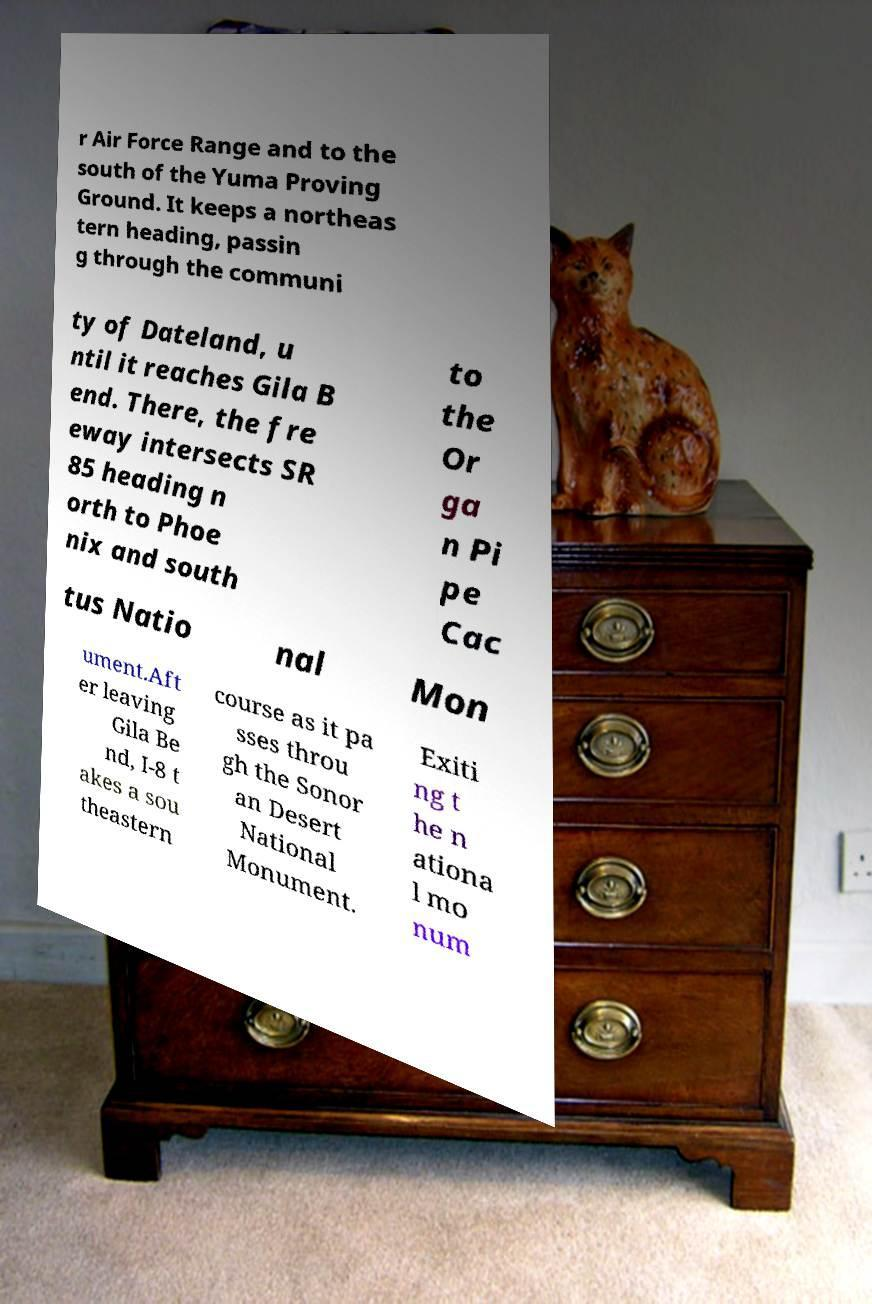For documentation purposes, I need the text within this image transcribed. Could you provide that? r Air Force Range and to the south of the Yuma Proving Ground. It keeps a northeas tern heading, passin g through the communi ty of Dateland, u ntil it reaches Gila B end. There, the fre eway intersects SR 85 heading n orth to Phoe nix and south to the Or ga n Pi pe Cac tus Natio nal Mon ument.Aft er leaving Gila Be nd, I-8 t akes a sou theastern course as it pa sses throu gh the Sonor an Desert National Monument. Exiti ng t he n ationa l mo num 